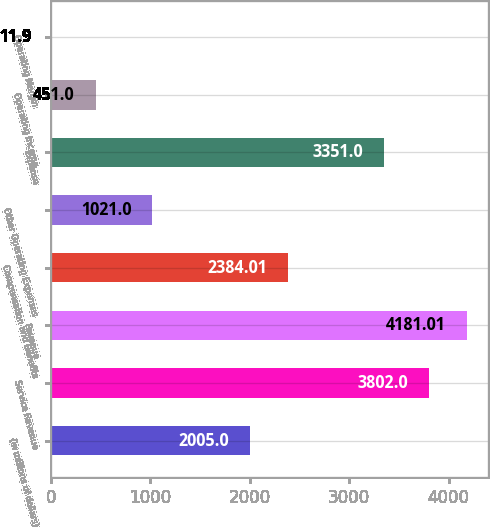<chart> <loc_0><loc_0><loc_500><loc_500><bar_chart><fcel>(In millions of dollars)<fcel>Service Revenue<fcel>Revenue<fcel>Compensation and Benefits<fcel>Other Operating Expenses<fcel>Expense<fcel>Operating Income<fcel>Operating Margin<nl><fcel>2005<fcel>3802<fcel>4181.01<fcel>2384.01<fcel>1021<fcel>3351<fcel>451<fcel>11.9<nl></chart> 